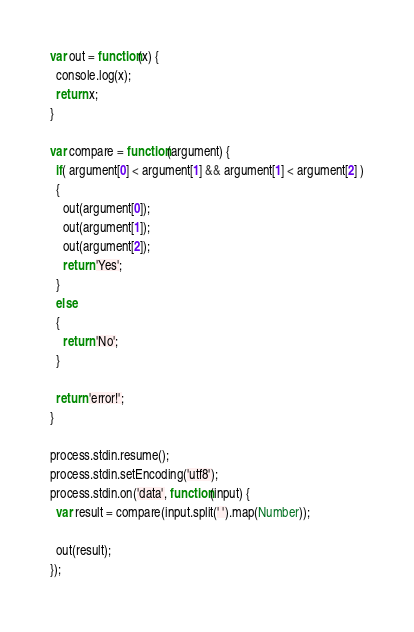Convert code to text. <code><loc_0><loc_0><loc_500><loc_500><_JavaScript_>var out = function(x) {
  console.log(x);
  return x;
}

var compare = function(argument) {
  if( argument[0] < argument[1] && argument[1] < argument[2] )
  {
    out(argument[0]);
    out(argument[1]);
    out(argument[2]);
    return 'Yes';
  }
  else
  {
    return 'No';
  }

  return 'error!';
}

process.stdin.resume();
process.stdin.setEncoding('utf8');
process.stdin.on('data', function(input) {
  var result = compare(input.split(' ').map(Number));

  out(result);
});</code> 